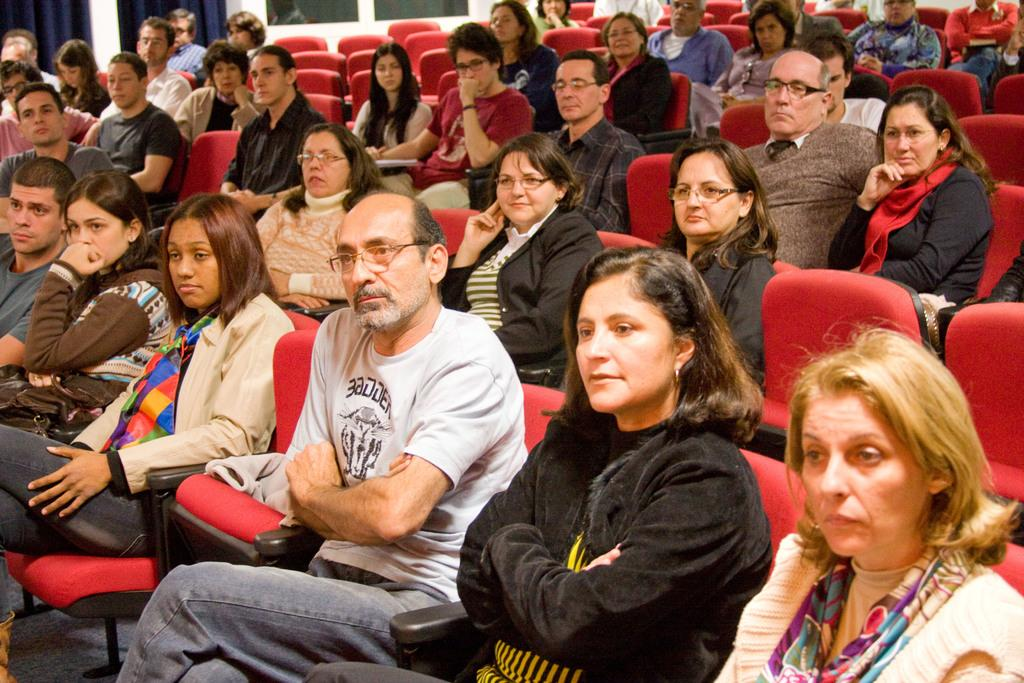How many people are in the image? There are persons in the image, but the exact number is not specified. What are the persons wearing? The persons are wearing clothes. What are the persons doing in the image? The persons are sitting on chairs. What type of fowl can be seen wearing a badge in the image? There is no fowl or badge present in the image. How many nails are visible in the image? There is no mention of nails in the provided facts, so it cannot be determined from the image. 